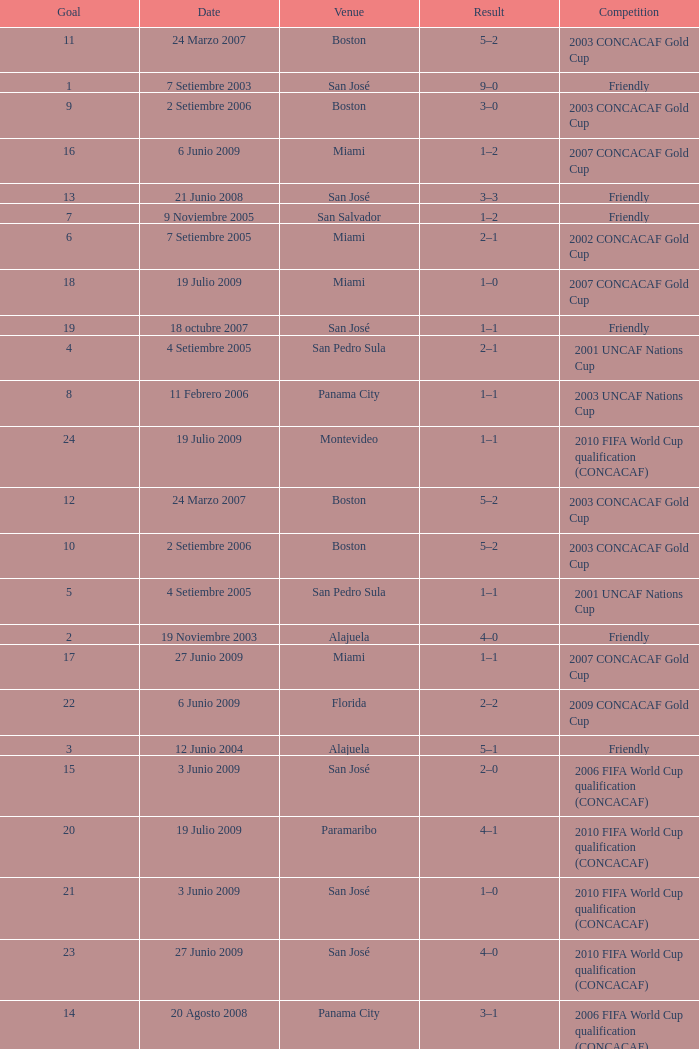How many goals were scored on 21 Junio 2008? 1.0. 